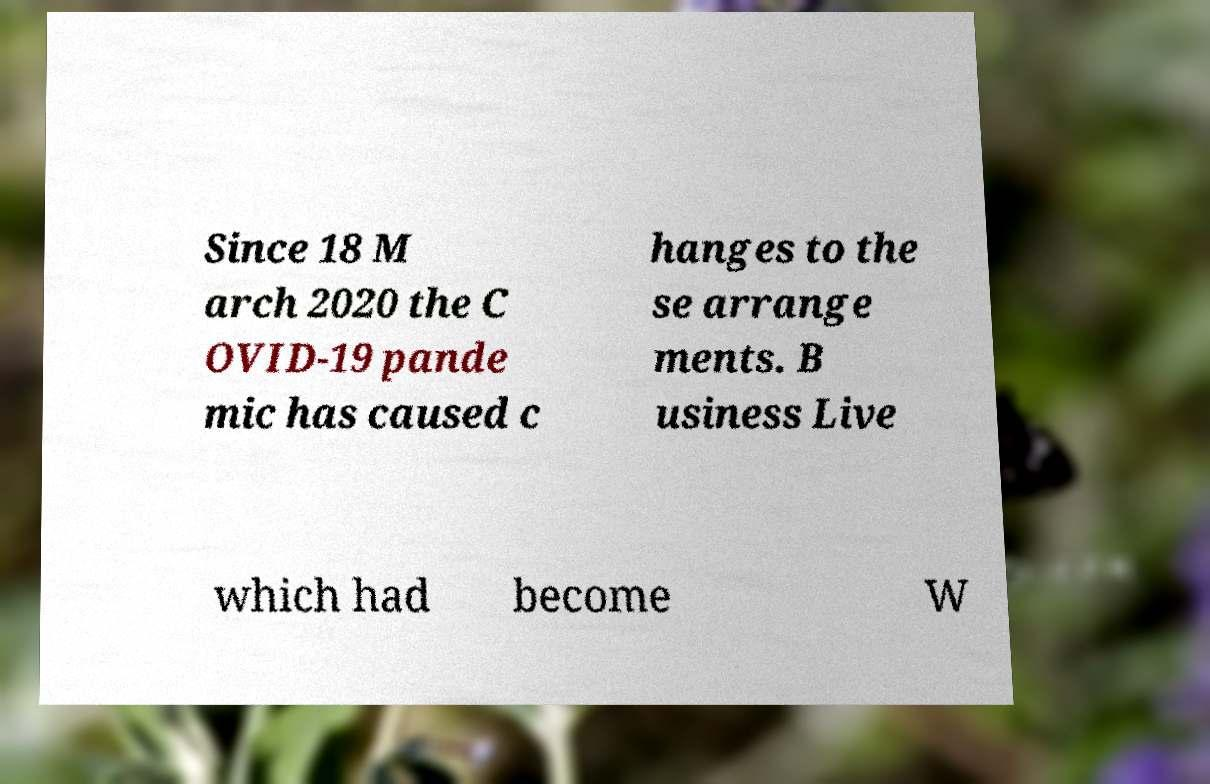Could you assist in decoding the text presented in this image and type it out clearly? Since 18 M arch 2020 the C OVID-19 pande mic has caused c hanges to the se arrange ments. B usiness Live which had become W 